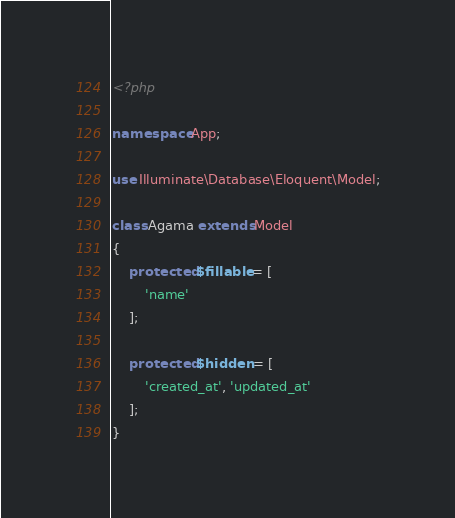Convert code to text. <code><loc_0><loc_0><loc_500><loc_500><_PHP_><?php

namespace App;

use Illuminate\Database\Eloquent\Model;

class Agama extends Model
{
    protected $fillable = [
        'name'
    ];

    protected $hidden = [
        'created_at', 'updated_at'
    ];
}
</code> 